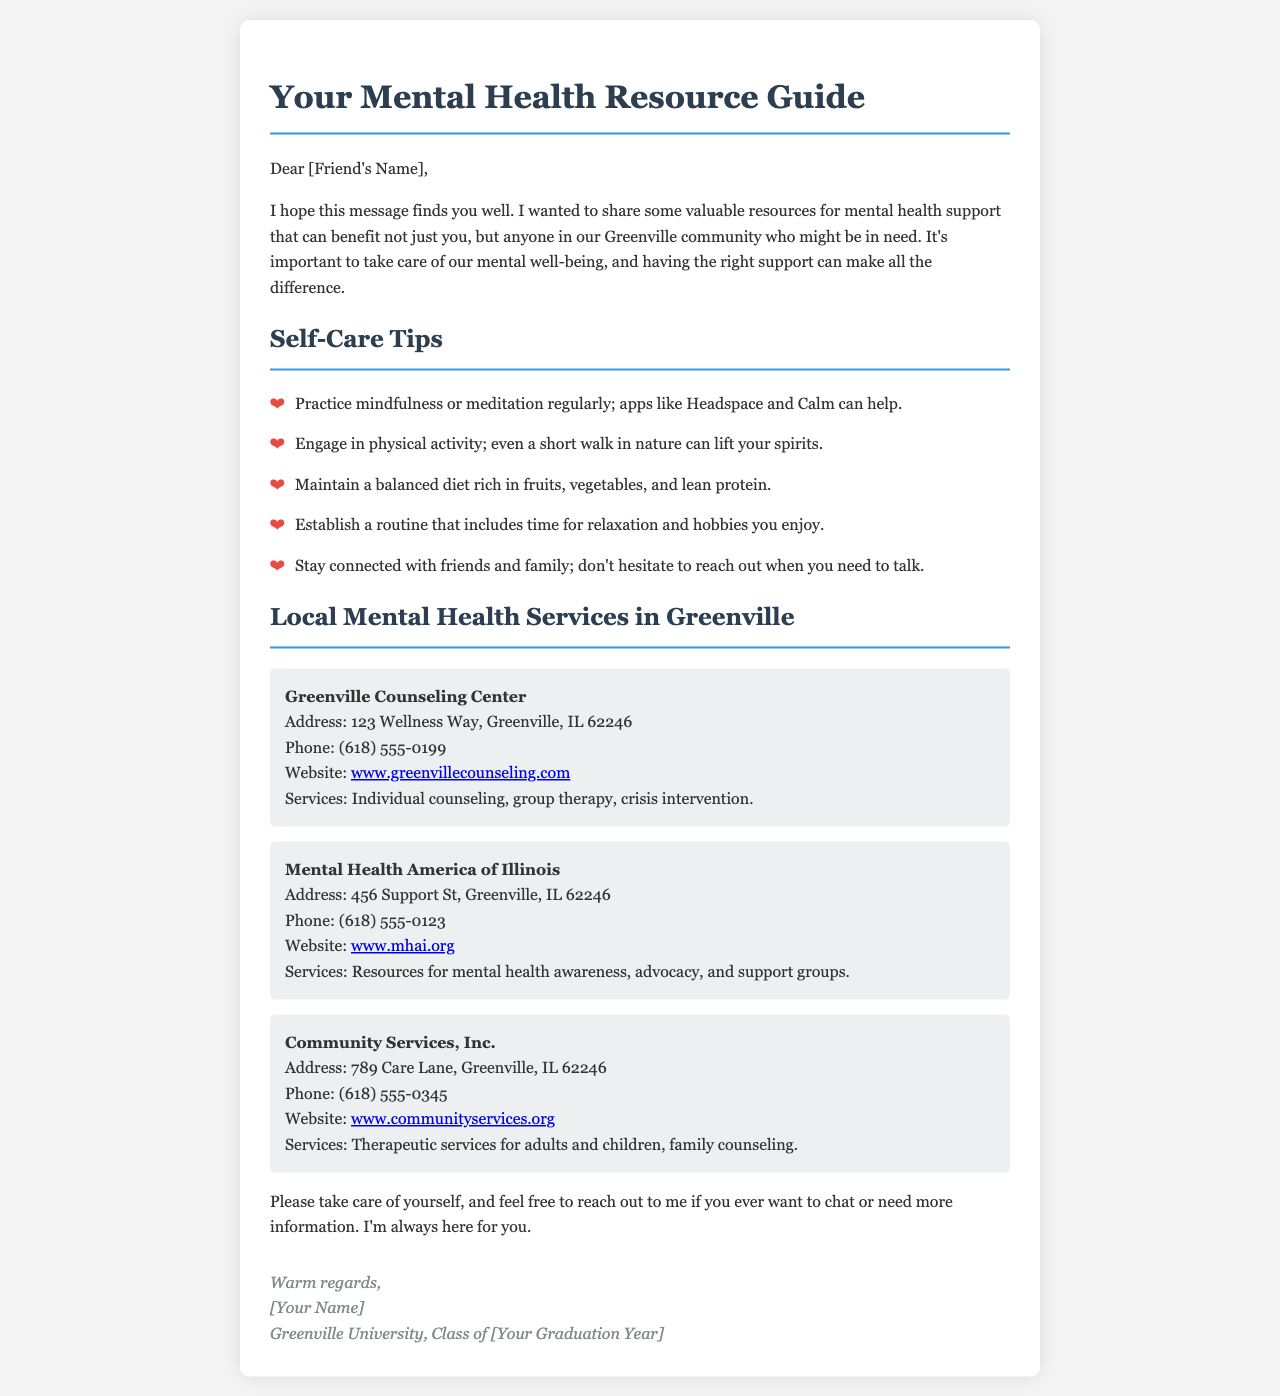What is the title of the document? The title of the document is found in the header.
Answer: Your Mental Health Resource Guide What is the name of the first mental health service listed? The first service mentioned in the document is listed under the local services section.
Answer: Greenville Counseling Center What is the phone number for Mental Health America of Illinois? The phone number can be found in the details of the listed services.
Answer: (618) 555-0123 What is one of the self-care tips provided? There are several self-care tips listed, and one of them can be selected from the tips list.
Answer: Practice mindfulness or meditation regularly How many local mental health services are mentioned in the document? The total count of the local services mentioned can be calculated by counting the list items in that section.
Answer: Three What is the address of Community Services, Inc.? The address is provided under the description of the respective service.
Answer: 789 Care Lane, Greenville, IL 62246 What type of document is this? The document is structured as a message that provides resources to someone, indicating it's a personal communication.
Answer: An email What is the signature style at the end of the document? The signature's style can be inferred from its formatting and tone at the document's conclusion.
Answer: Italicized What suggestion is made for maintaining social connections? There is a specific recommendation in the self-care tips regarding social connections.
Answer: Stay connected with friends and family 